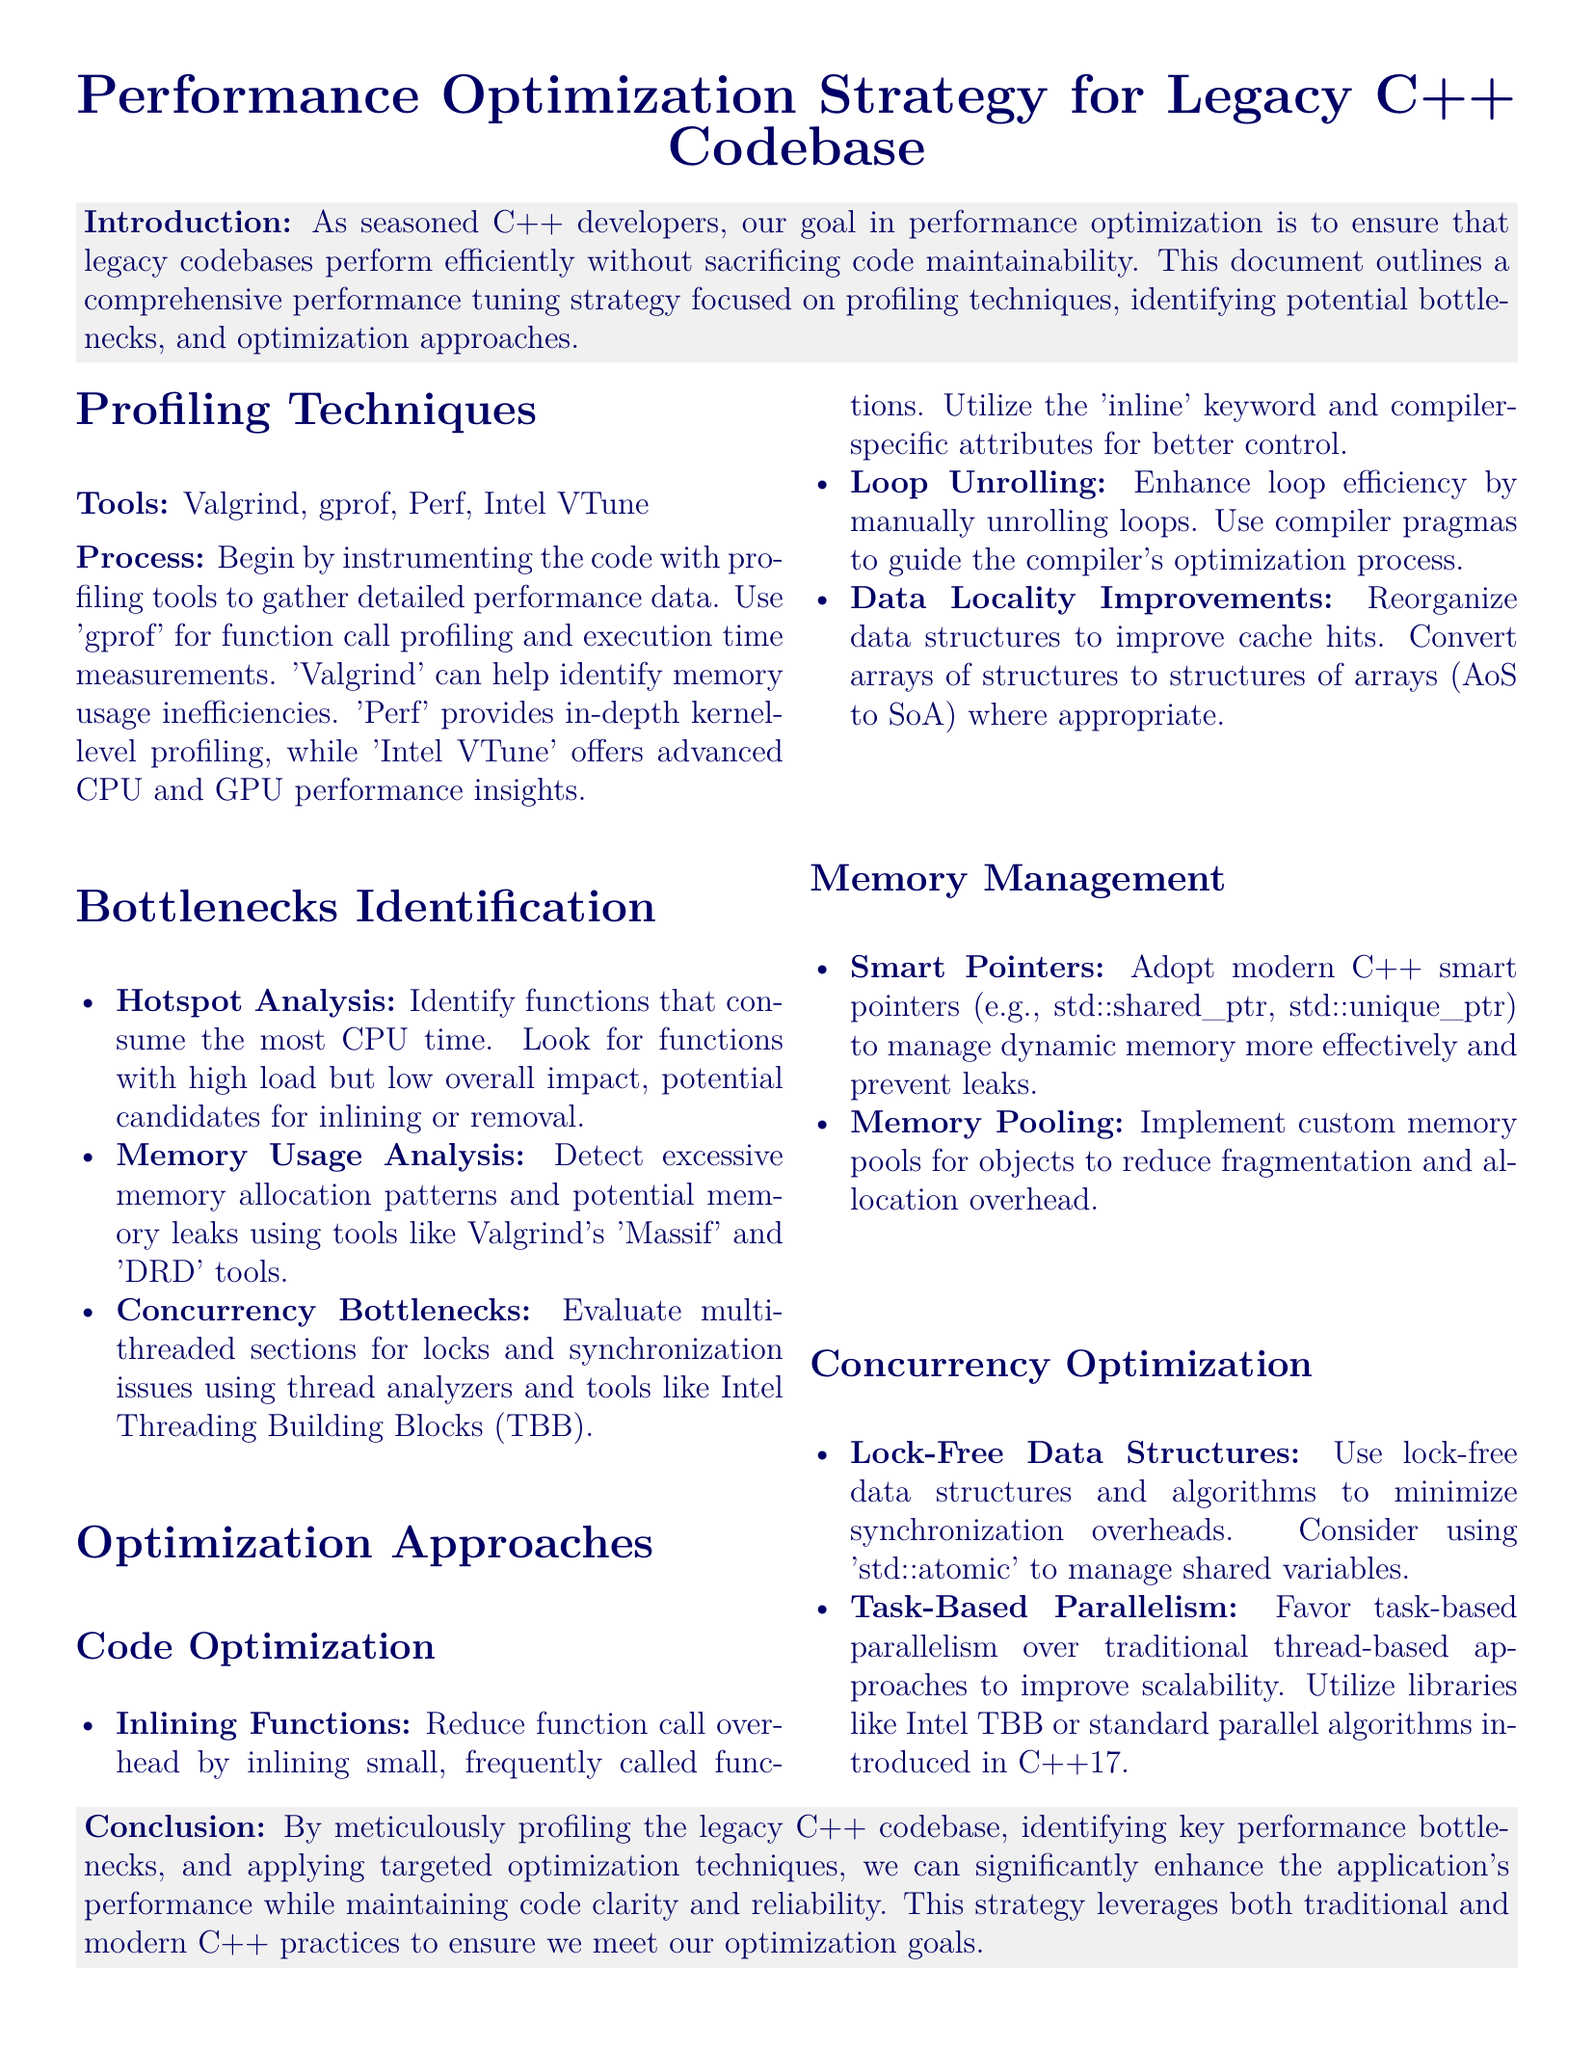What is the title of the document? The title presents the subject of the document clearly, which is "Performance Optimization Strategy for Legacy C++ Codebase".
Answer: Performance Optimization Strategy for Legacy C++ Codebase What profiling tool is mentioned first? The document lists several profiling tools, with Valgrind as the first mentioned.
Answer: Valgrind What technique is used for hotspot analysis? The technique identifies functions that consume the most CPU time as a method of detecting performance issues.
Answer: Hotspot Analysis Which optimization approach focuses on dynamic memory management? The section that discusses memory management techniques aims to enhance memory use in C++.
Answer: Memory Management What type of parallelism is suggested for optimization? The document advises using task-based parallelism over traditional methods to improve performance.
Answer: Task-Based Parallelism What is the primary goal of the performance optimization strategy? The primary aim is to enhance application performance while maintaining code clarity and reliability.
Answer: Enhance performance while maintaining clarity and reliability What does the abbreviation TBB stand for? The abbreviation refers to Intel Threading Building Blocks, a library for concurrency optimization.
Answer: Intel Threading Building Blocks In what section is loop unrolling discussed? Loop unrolling is mentioned under the optimization techniques section related to code optimization.
Answer: Code Optimization 